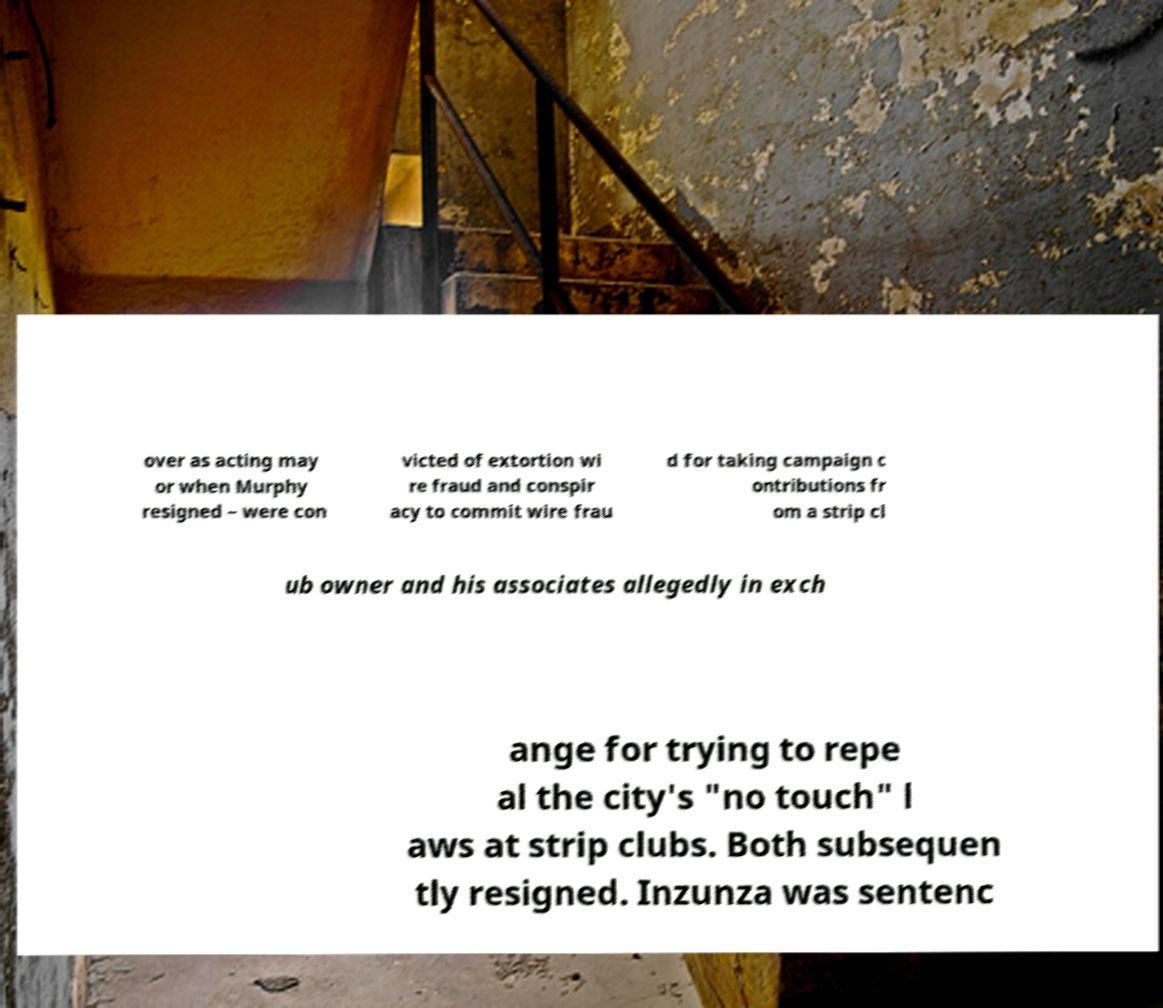Could you extract and type out the text from this image? over as acting may or when Murphy resigned – were con victed of extortion wi re fraud and conspir acy to commit wire frau d for taking campaign c ontributions fr om a strip cl ub owner and his associates allegedly in exch ange for trying to repe al the city's "no touch" l aws at strip clubs. Both subsequen tly resigned. Inzunza was sentenc 